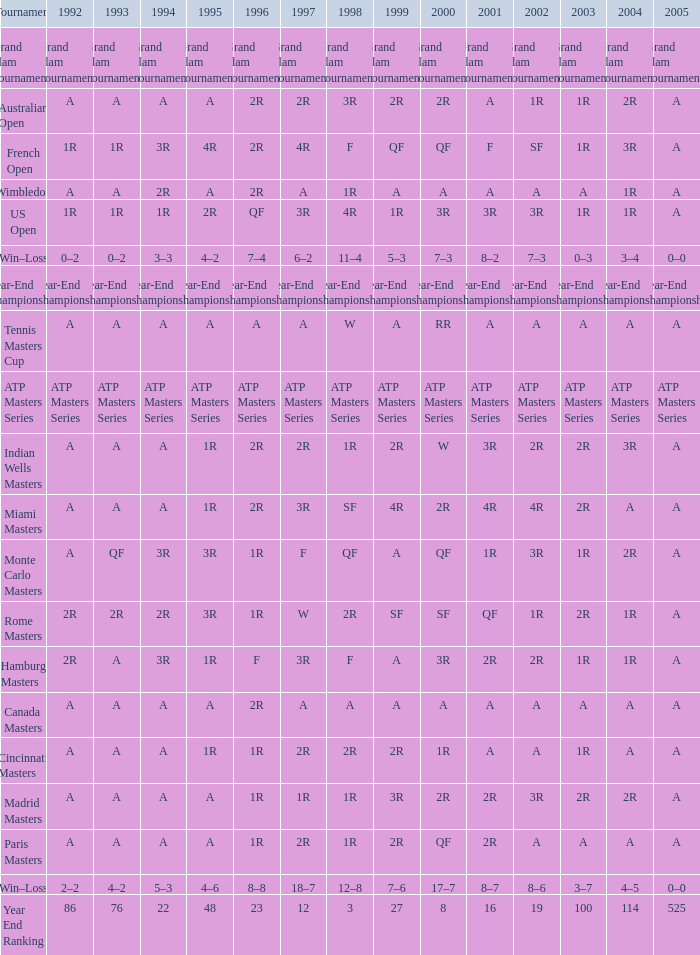What is 1998, when 1997 is "3R", and when 1992 is "A"? SF. 